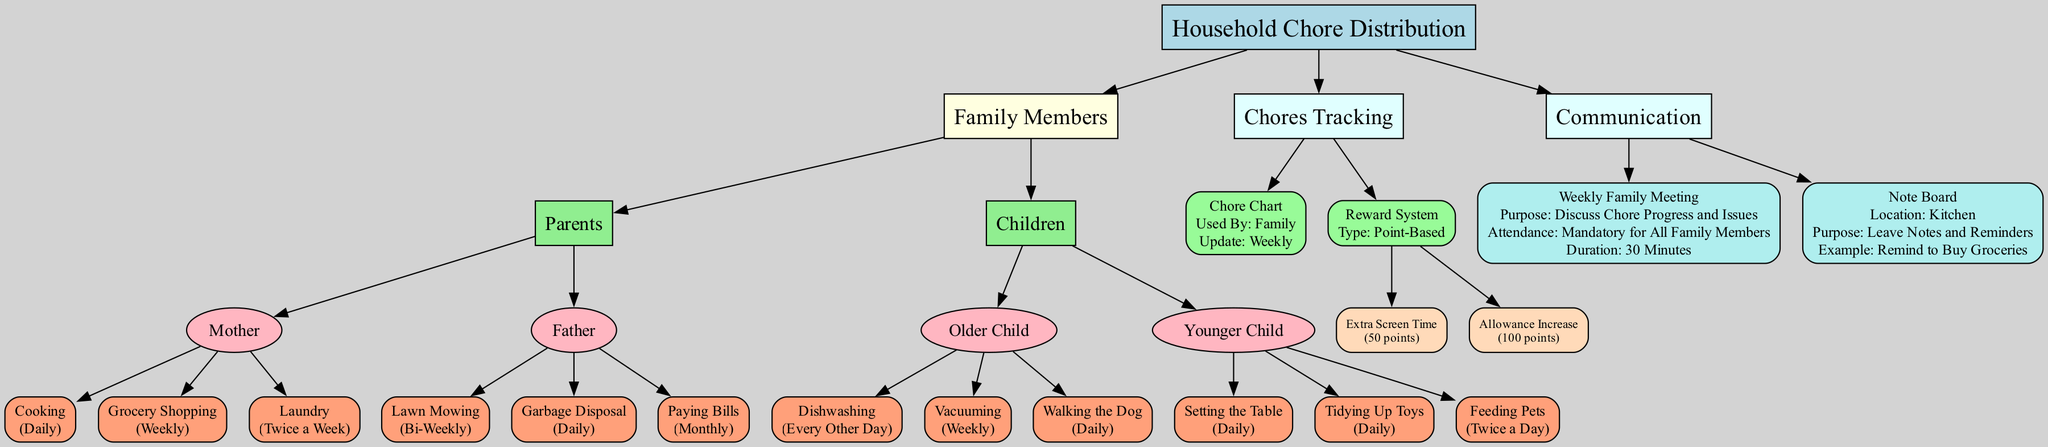What chores does the Mother do? The diagram shows that the Mother is responsible for three chores: Cooking, Grocery Shopping, and Laundry. These are directly connected to the Mother node in the diagram.
Answer: Cooking, Grocery Shopping, Laundry How often does the Younger Child feed pets? The frequency for feeding pets is indicated as "Twice a Day" next to the chore connected to the Younger Child in the diagram.
Answer: Twice a Day What is the purpose of the Weekly Family Meeting? The diagram states that the purpose is to "Discuss Chore Progress and Issues," which is shown in the detail associated with the Weekly Family Meeting node.
Answer: Discuss Chore Progress and Issues How many rewards are listed in the Reward System? The diagram lists two rewards: Extra Screen Time and Allowance Increase. By counting these rewards connected to the Reward System node, we find there are two.
Answer: 2 Which family member handles Garbage Disposal? The diagram indicates that the Father is responsible for Garbage Disposal, as it is directly linked to the Father node.
Answer: Father What is the update frequency for the Chore Chart? The Chore Chart's update frequency is specified as "Weekly" next to the Chore Chart node in the diagram.
Answer: Weekly What is the location of the Note Board? According to the diagram, the location of the Note Board is the "Kitchen" as described next to the Note Board node.
Answer: Kitchen What type of reward system is used? The diagram indicates that the type of reward system used is "Point-Based," mentioned in the details under the Reward System node.
Answer: Point-Based What chore is done by the Older Child daily? The diagram lists "Walking the Dog" as a chore that the Older Child performs daily, showing it connected from the Older Child node with the corresponding frequency.
Answer: Walking the Dog 